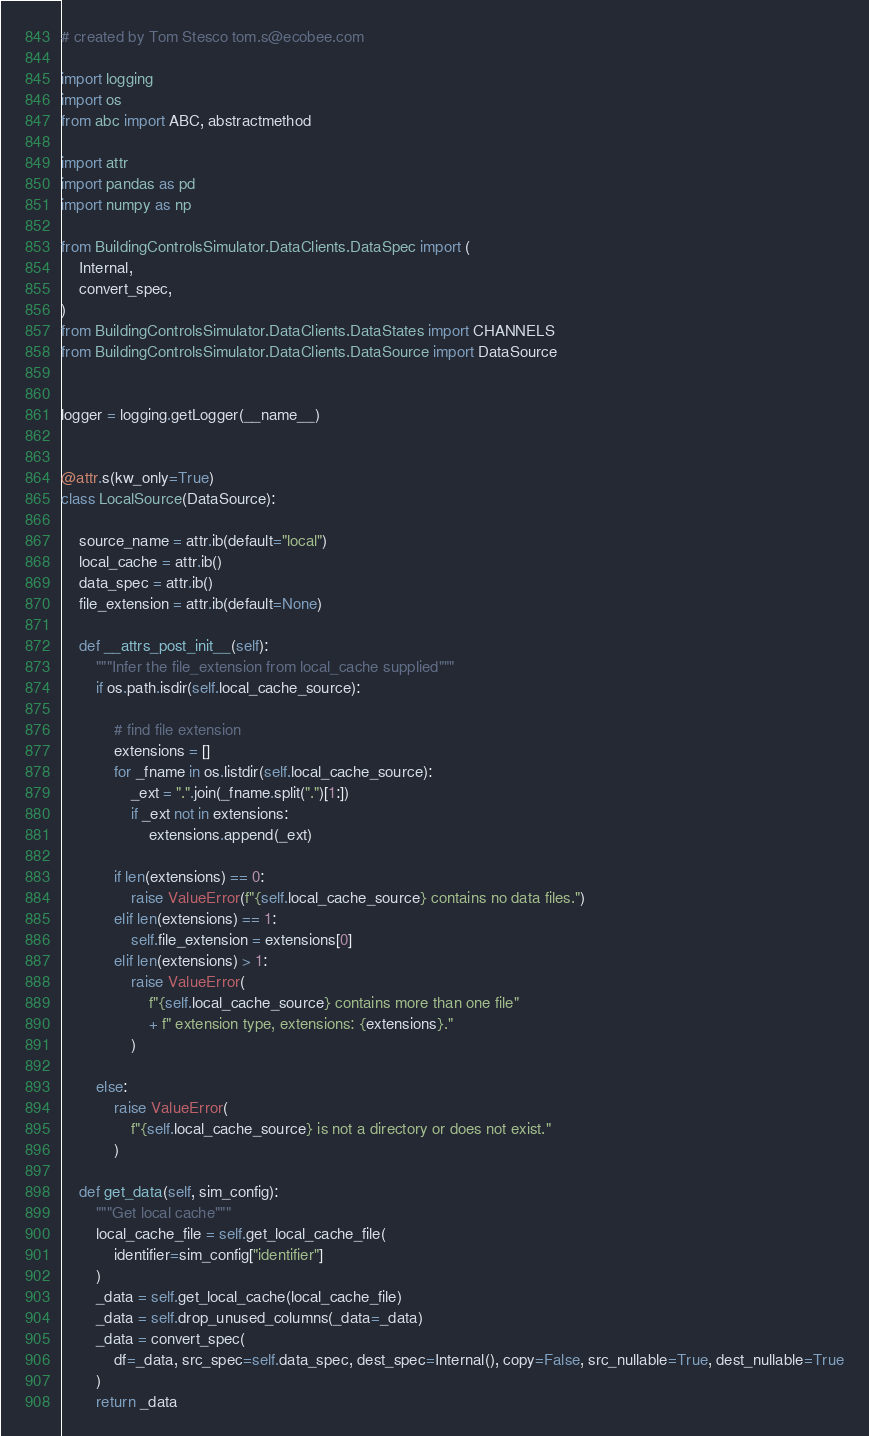Convert code to text. <code><loc_0><loc_0><loc_500><loc_500><_Python_># created by Tom Stesco tom.s@ecobee.com

import logging
import os
from abc import ABC, abstractmethod

import attr
import pandas as pd
import numpy as np

from BuildingControlsSimulator.DataClients.DataSpec import (
    Internal,
    convert_spec,
)
from BuildingControlsSimulator.DataClients.DataStates import CHANNELS
from BuildingControlsSimulator.DataClients.DataSource import DataSource


logger = logging.getLogger(__name__)


@attr.s(kw_only=True)
class LocalSource(DataSource):

    source_name = attr.ib(default="local")
    local_cache = attr.ib()
    data_spec = attr.ib()
    file_extension = attr.ib(default=None)

    def __attrs_post_init__(self):
        """Infer the file_extension from local_cache supplied"""
        if os.path.isdir(self.local_cache_source):

            # find file extension
            extensions = []
            for _fname in os.listdir(self.local_cache_source):
                _ext = ".".join(_fname.split(".")[1:])
                if _ext not in extensions:
                    extensions.append(_ext)

            if len(extensions) == 0:
                raise ValueError(f"{self.local_cache_source} contains no data files.")
            elif len(extensions) == 1:
                self.file_extension = extensions[0]
            elif len(extensions) > 1:
                raise ValueError(
                    f"{self.local_cache_source} contains more than one file"
                    + f" extension type, extensions: {extensions}."
                )

        else:
            raise ValueError(
                f"{self.local_cache_source} is not a directory or does not exist."
            )

    def get_data(self, sim_config):
        """Get local cache"""
        local_cache_file = self.get_local_cache_file(
            identifier=sim_config["identifier"]
        )
        _data = self.get_local_cache(local_cache_file)
        _data = self.drop_unused_columns(_data=_data)
        _data = convert_spec(
            df=_data, src_spec=self.data_spec, dest_spec=Internal(), copy=False, src_nullable=True, dest_nullable=True
        )
        return _data
</code> 